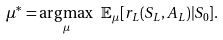Convert formula to latex. <formula><loc_0><loc_0><loc_500><loc_500>\mu ^ { * } = \underset { \mu } { \arg \max } \ \mathbb { E } _ { \mu } [ r _ { L } ( S _ { L } , A _ { L } ) | S _ { 0 } ] .</formula> 